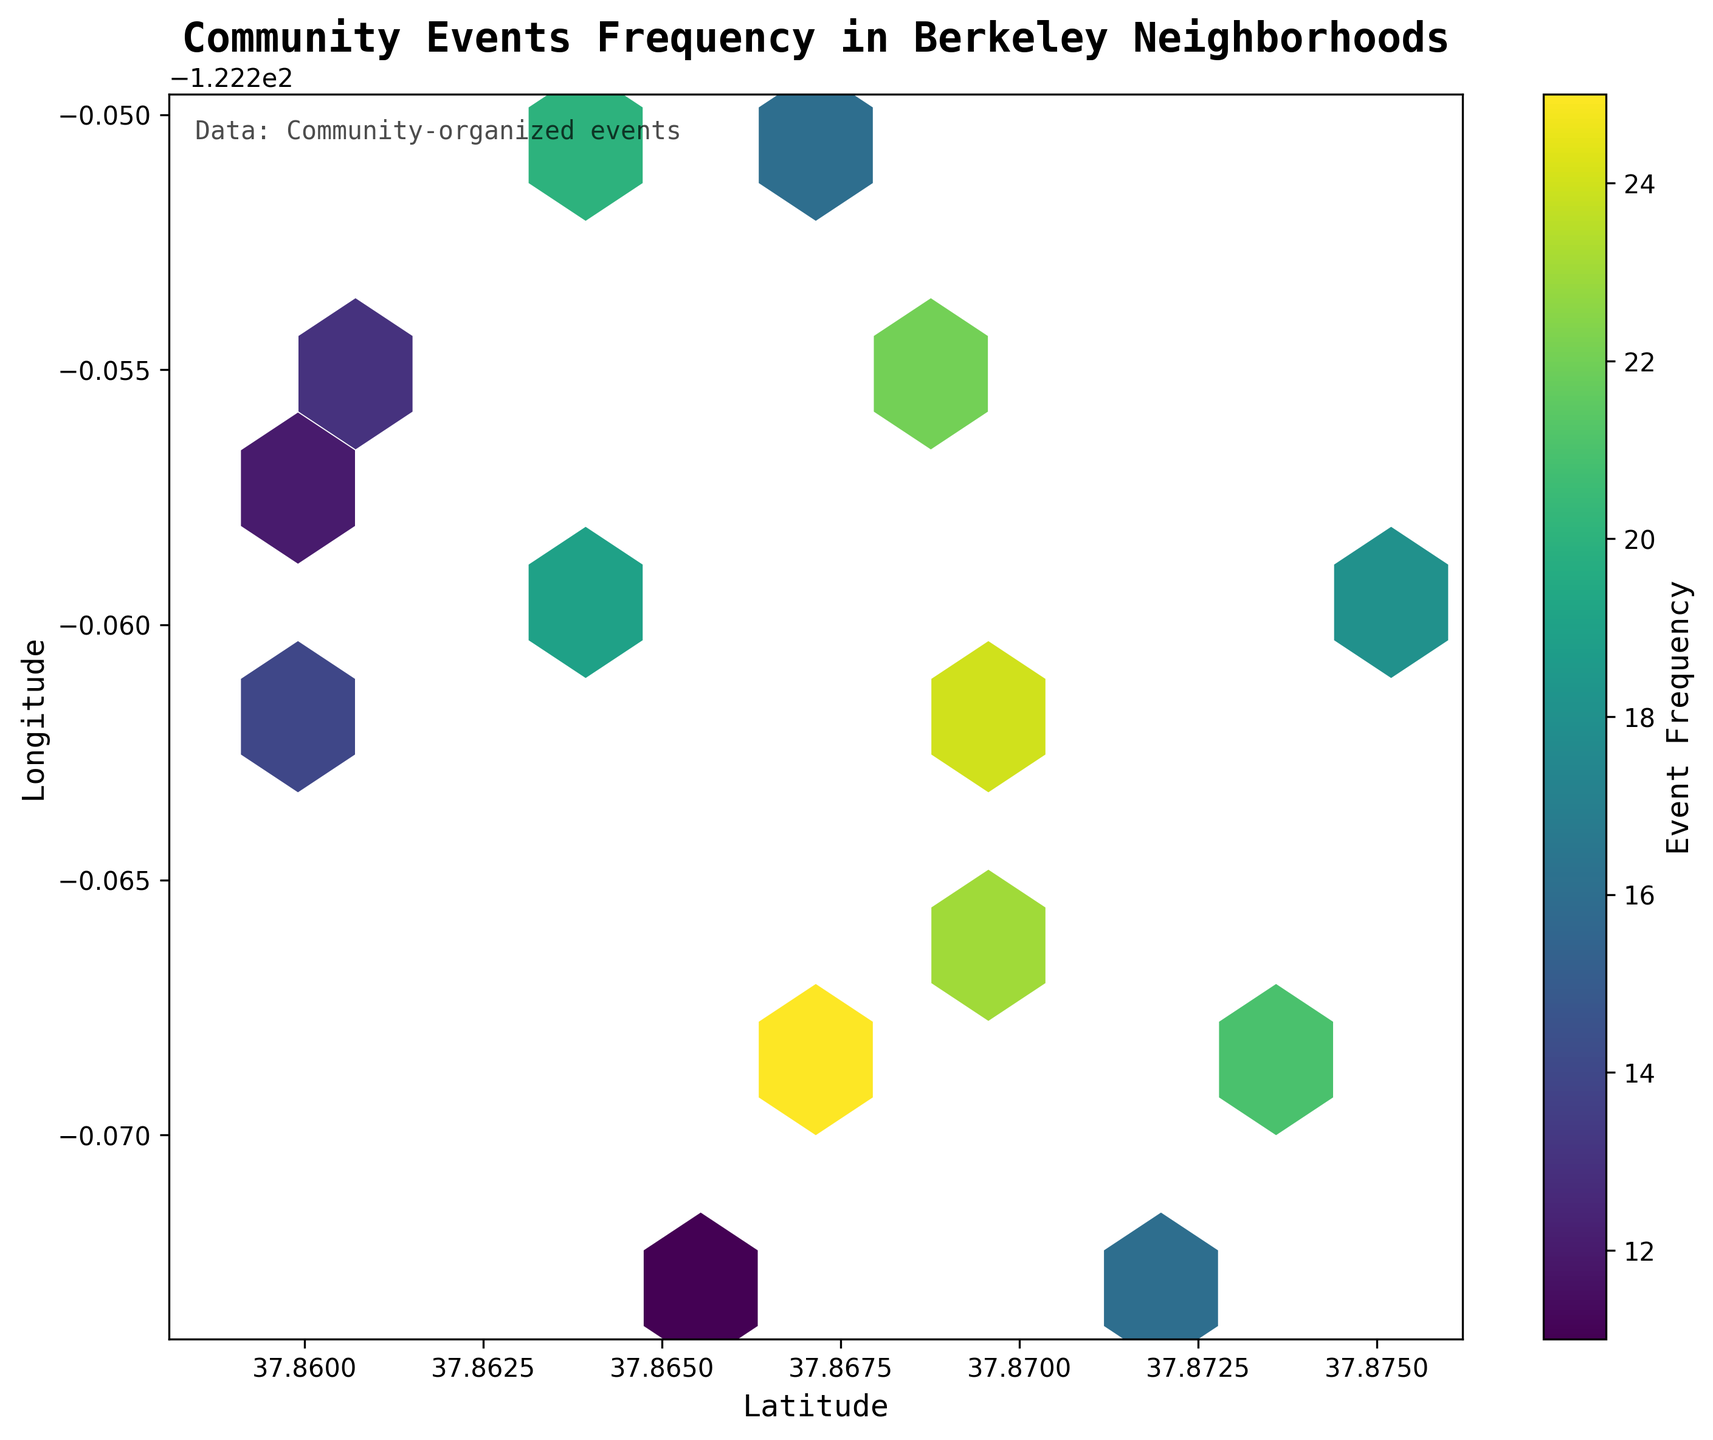What is the title of the figure? The title is usually found at the top of the figure. In this case, the title "Community Events Frequency in Berkeley Neighborhoods" is displayed prominently in bold, large font.
Answer: Community Events Frequency in Berkeley Neighborhoods What do the colors represent in the Hexbin Plot? The color gradient in a Hexbin Plot typically indicates the density or intensity of the measured variable. The color bar on the side shows that darker colors represent higher frequencies of community-organized events.
Answer: Event frequency How many hexagons are displayed in the plot? To count the hexagons, you need to observe the individual hexagon shapes within the plot area. Each hexagon represents a data aggregation area.
Answer: 15 Which neighborhood has the highest frequency of community events? Find the darkest hexagon in the plot, which represents the highest frequency of events. The corresponding coordinates near this hexagon will indicate the location.
Answer: Neighborhood around latitude 37.8677, longitude -122.2678 What is the frequency range displayed on the color bar? Observe the numerical labels on the color bar on the side of the plot. The range defines the minimum and maximum frequency values represented in the plot.
Answer: 11 to 25 How does the frequency vary from east to west in Berkeley? Analyze the pattern of hexagon colors (density) and observe the gradient from the left-most (west) to the right-most (east) side of the plot. Typically, the frequency may change, indicating different community engagement levels across these areas.
Answer: Varies; generally higher frequency in some central areas What is the average frequency value of events shown in the figure? Sum all the frequency values for the hexagons and divide by the total number of hexagons displayed. The average can be found by computing the sum of all given frequencies (15 + 22 + 18 + 25 + 12 + 20 + 17 + 14 + 23 + 19 + 16 + 21 + 13 + 24 + 11) and dividing by 15 (number of hexagons). (15 + 22 + 18 + 25 + 12 + 20 + 17 + 14 + 23 + 19 + 16 + 21 + 13 + 24 + 11) / 15 = 20
Answer: 18.2 Which areas in Berkeley have a frequency lower than 15? Identify hexagons with colors indicating frequencies lower than 15, then check their coordinates or general regions on the plot.
Answer: South-western regions Which neighborhood coordinates have the lowest event frequency? Locate the lightest hexagon on the plot, referring to the specific coordinates shown near that hexagon. The lowest frequency would be the minimum value on the color bar.
Answer: Neighborhood around latitude 37.8650, longitude -122.2730 (Frequency = 11) What does the hexbin plot reveal about community-organized events frequency distribution in east Berkeley compared to west Berkeley? Analyze the density and color differences between the hexagons in the east and west parts of the plot. East Berkeley's frequency distribution might be sparser, or frequencies could be higher/lower based on coloration.
Answer: More varied and slightly higher in central-west regions 